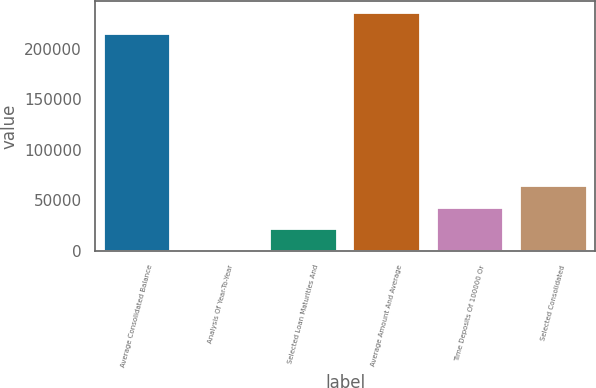<chart> <loc_0><loc_0><loc_500><loc_500><bar_chart><fcel>Average Consolidated Balance<fcel>Analysis Of Year-To-Year<fcel>Selected Loan Maturities And<fcel>Average Amount And Average<fcel>Time Deposits Of 100000 Or<fcel>Selected Consolidated<nl><fcel>214215<fcel>216<fcel>21615.9<fcel>235615<fcel>43015.8<fcel>64415.7<nl></chart> 